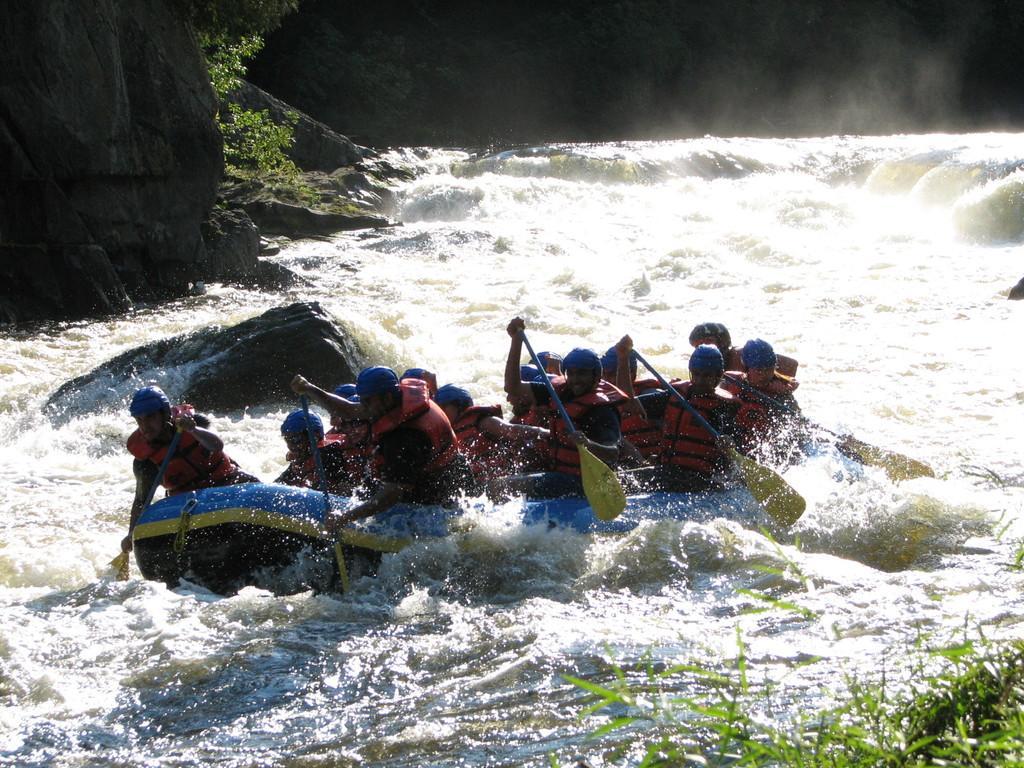Describe this image in one or two sentences. In this image, we can see a few people rafting. We can see some stones and plants. We can also see some grass on the bottom right corner. 